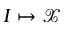<formula> <loc_0><loc_0><loc_500><loc_500>I \mapsto \mathcal { X }</formula> 